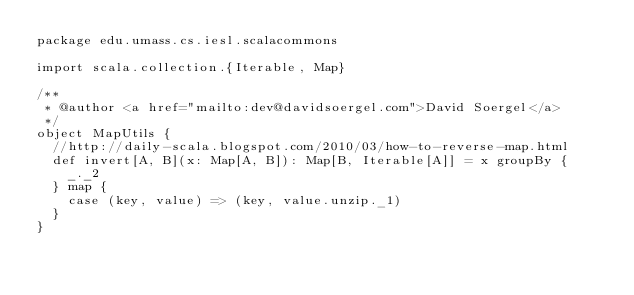<code> <loc_0><loc_0><loc_500><loc_500><_Scala_>package edu.umass.cs.iesl.scalacommons

import scala.collection.{Iterable, Map}

/**
 * @author <a href="mailto:dev@davidsoergel.com">David Soergel</a>
 */
object MapUtils {
  //http://daily-scala.blogspot.com/2010/03/how-to-reverse-map.html
  def invert[A, B](x: Map[A, B]): Map[B, Iterable[A]] = x groupBy {
    _._2
  } map {
    case (key, value) => (key, value.unzip._1)
  }
}
</code> 